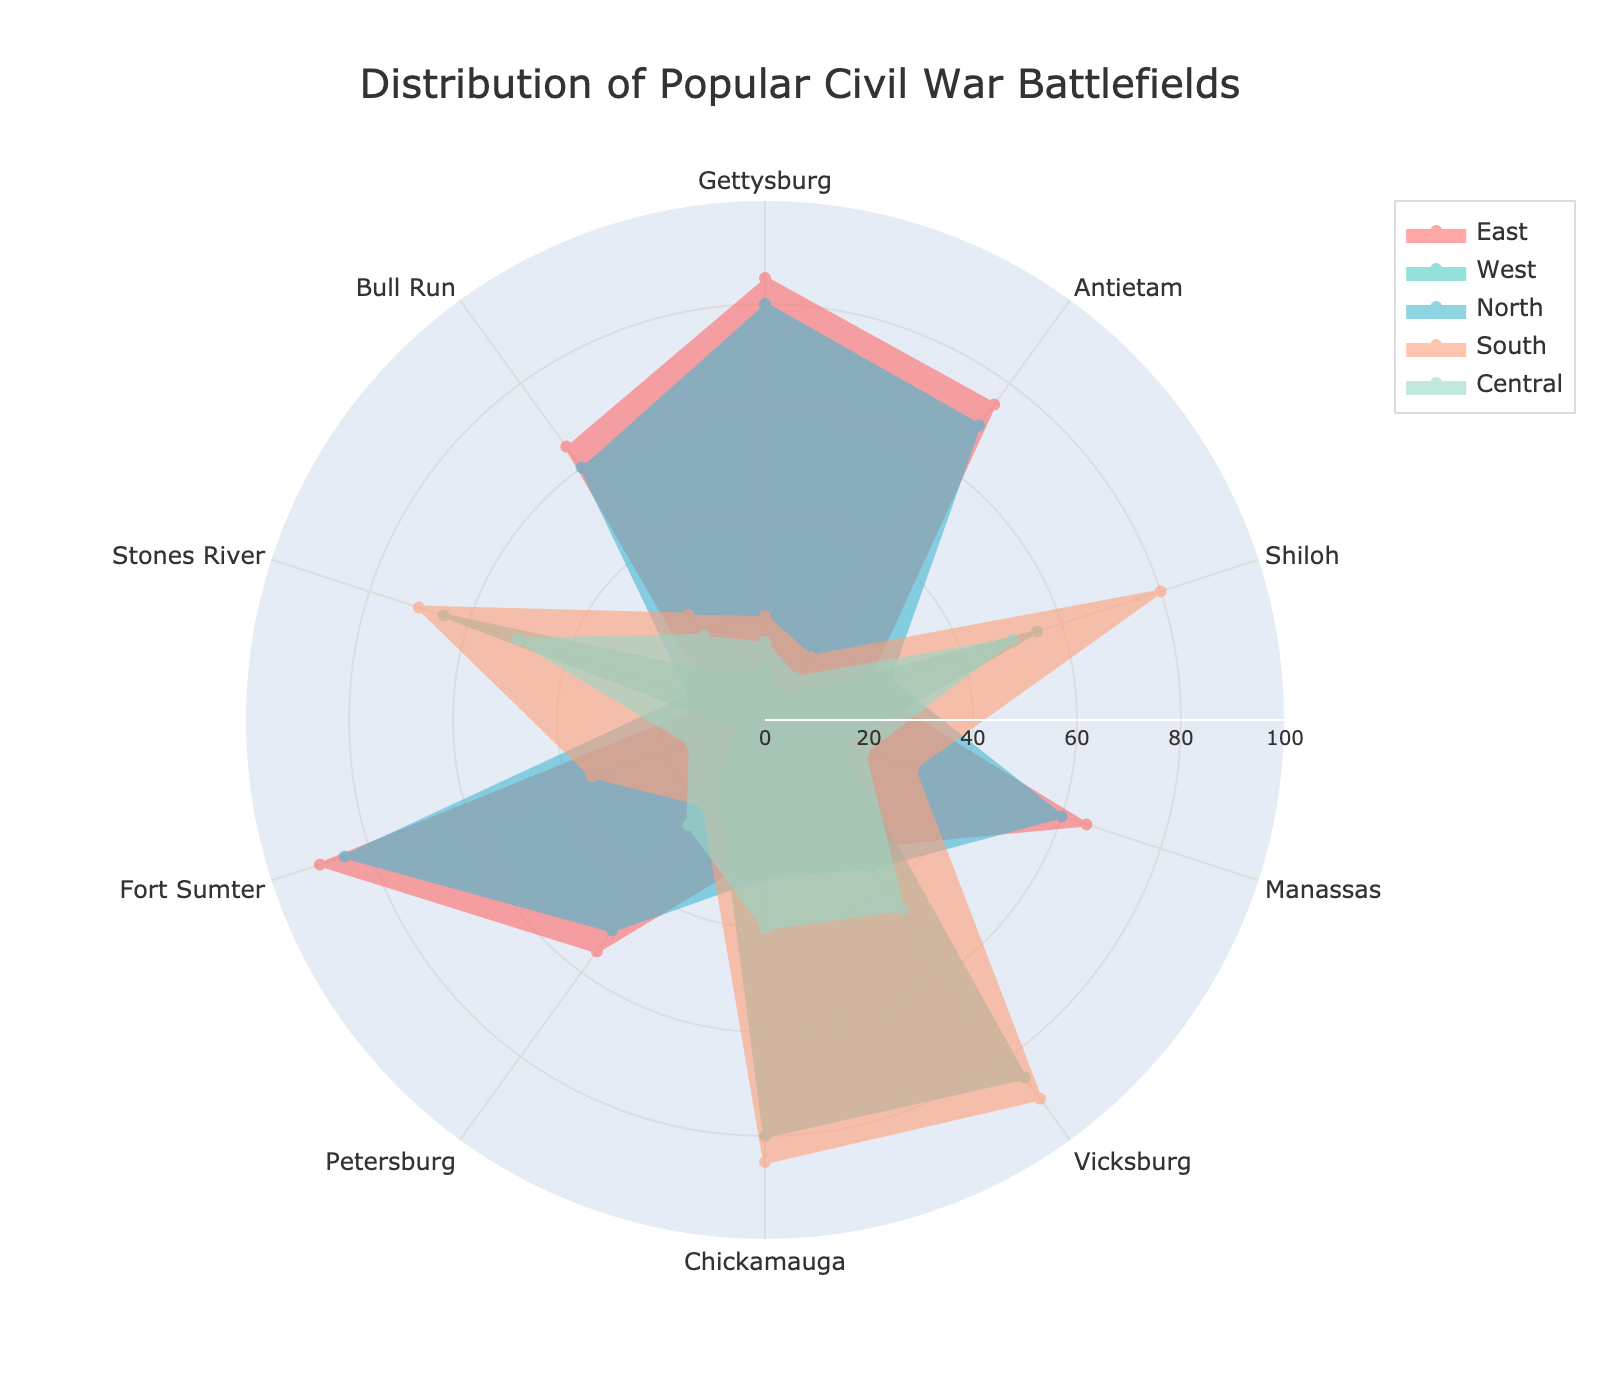What is the title of the radar chart? The title of the radar chart is prominently displayed at the top of the figure.
Answer: Distribution of Popular Civil War Battlefields Which battlefield has the highest popularity in the South? By looking at the radar chart, you can see that for the South category, the highest value among the battlefields is represented by the longest spoke.
Answer: Vicksburg How many geographic locations are compared in this radar chart? Count the number of distinct regions or groups represented in the radar chart, which usually correspond to the different traces.
Answer: 5 Which battlefield is the least visited in the North? In the North category, identify the spoke with the smallest value.
Answer: Stones River Compare the popularity of Gettysburg between the East and the West. For Gettysburg, gauge the length of the spokes in the East and West categories. The East's value is higher.
Answer: East is more popular What's the average popularity of Shiloh across all geographic regions? Sum the values of Shiloh from all regions and divide by the total number of regions: (20+55+25+80+50)/5 = 230/5 = 46
Answer: 46 Which geographic location has the most balanced distribution of visited battlefields? Look for the category where the spokes are more or less of equal length, indicating a balanced interest across all battlefields.
Answer: Central What is the difference in popularity of Fort Sumter between the South and the West? Subtract the value of Fort Sumter in the West from that in the South using the data provided (35 - 5).
Answer: 30 Identify the battlefield visited equally frequent in both the East and the North. Find a battlefield where the spokes for both the East and North categories have the same length.
Answer: Fort Sumter Which battlefield in the East has a popularity value greater than 60 but less than 90? Observe the East category and identify any battlefields with values within the specified range.
Answer: Gettysburg, Antietam, Fort Sumter 